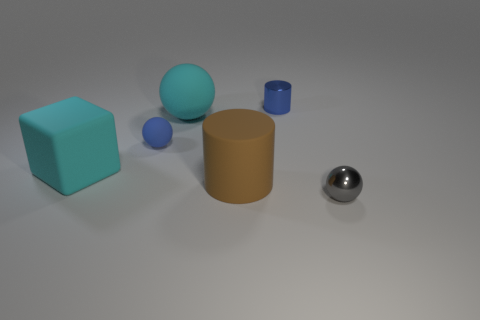Add 2 tiny yellow shiny balls. How many objects exist? 8 Subtract all cubes. How many objects are left? 5 Subtract all cyan rubber balls. Subtract all big matte blocks. How many objects are left? 4 Add 6 metallic balls. How many metallic balls are left? 7 Add 2 tiny purple balls. How many tiny purple balls exist? 2 Subtract 0 blue cubes. How many objects are left? 6 